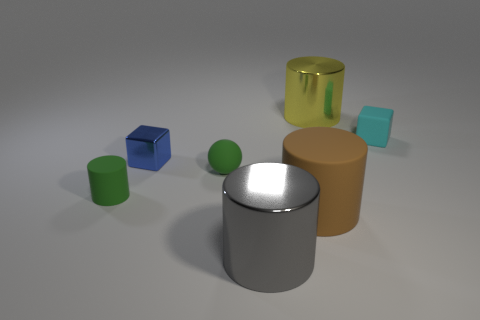Subtract all large gray metal cylinders. How many cylinders are left? 3 Add 2 brown matte objects. How many objects exist? 9 Subtract all green cylinders. How many cylinders are left? 3 Subtract 2 cylinders. How many cylinders are left? 2 Subtract all cylinders. How many objects are left? 3 Subtract all green cylinders. Subtract all purple balls. How many cylinders are left? 3 Add 1 big cyan rubber objects. How many big cyan rubber objects exist? 1 Subtract 0 cyan balls. How many objects are left? 7 Subtract all blue metal things. Subtract all gray cylinders. How many objects are left? 5 Add 2 gray metal cylinders. How many gray metal cylinders are left? 3 